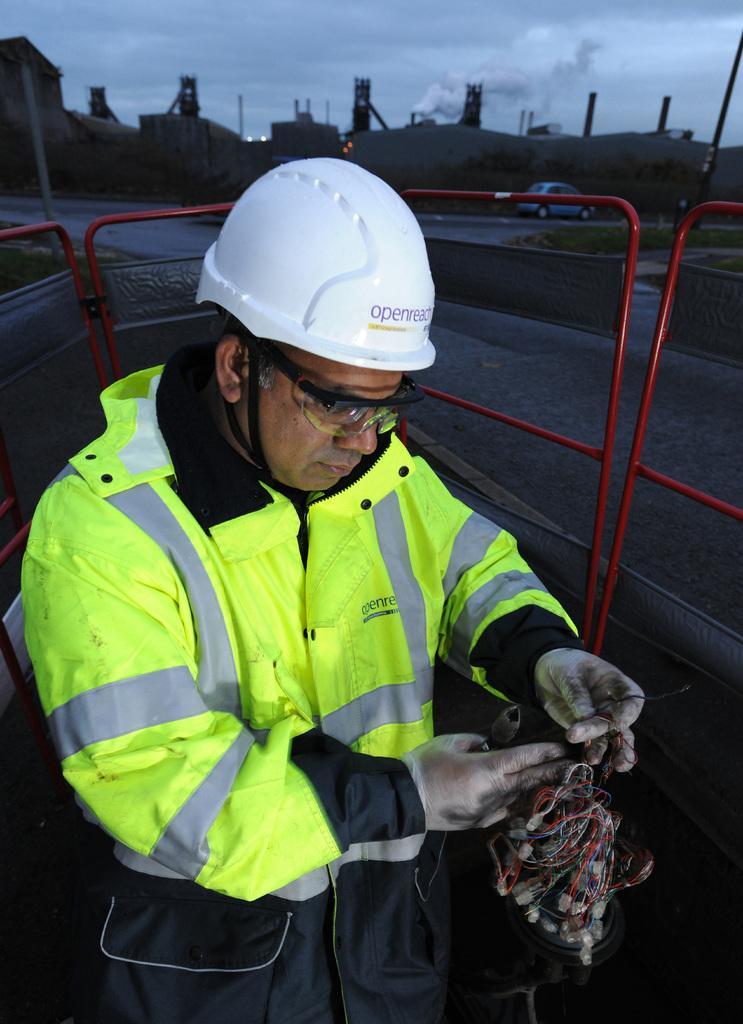In one or two sentences, can you explain what this image depicts? In this picture there is a man who is wearing helmet, goggles, gloves, jacket and trousers. He is holding a cloth and light. He is standing near to the fencing. In the back we can see buildings, shed, road and car. On the top we can see sky and clouds. Here we can see smoke which is coming from the exhaust tower. 